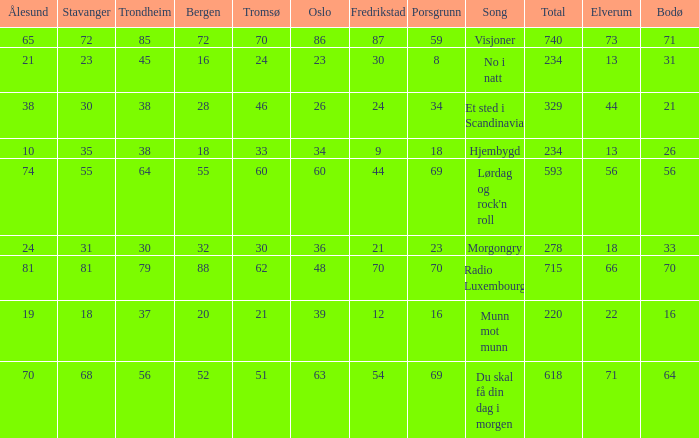What is the lowest total? 220.0. Can you parse all the data within this table? {'header': ['Ålesund', 'Stavanger', 'Trondheim', 'Bergen', 'Tromsø', 'Oslo', 'Fredrikstad', 'Porsgrunn', 'Song', 'Total', 'Elverum', 'Bodø'], 'rows': [['65', '72', '85', '72', '70', '86', '87', '59', 'Visjoner', '740', '73', '71'], ['21', '23', '45', '16', '24', '23', '30', '8', 'No i natt', '234', '13', '31'], ['38', '30', '38', '28', '46', '26', '24', '34', 'Et sted i Scandinavia', '329', '44', '21'], ['10', '35', '38', '18', '33', '34', '9', '18', 'Hjembygd', '234', '13', '26'], ['74', '55', '64', '55', '60', '60', '44', '69', "Lørdag og rock'n roll", '593', '56', '56'], ['24', '31', '30', '32', '30', '36', '21', '23', 'Morgongry', '278', '18', '33'], ['81', '81', '79', '88', '62', '48', '70', '70', 'Radio Luxembourg', '715', '66', '70'], ['19', '18', '37', '20', '21', '39', '12', '16', 'Munn mot munn', '220', '22', '16'], ['70', '68', '56', '52', '51', '63', '54', '69', 'Du skal få din dag i morgen', '618', '71', '64']]} 